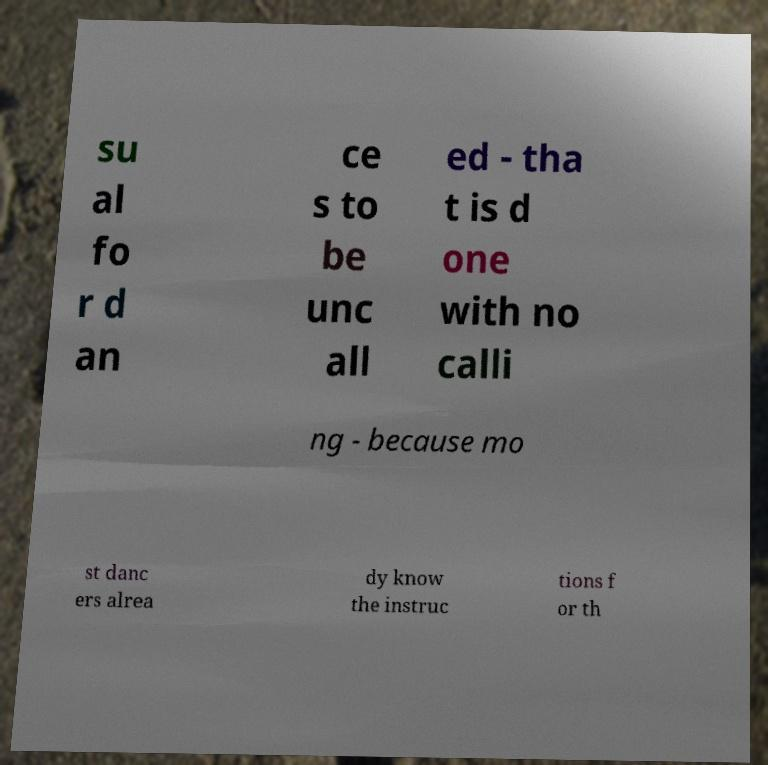What messages or text are displayed in this image? I need them in a readable, typed format. su al fo r d an ce s to be unc all ed - tha t is d one with no calli ng - because mo st danc ers alrea dy know the instruc tions f or th 